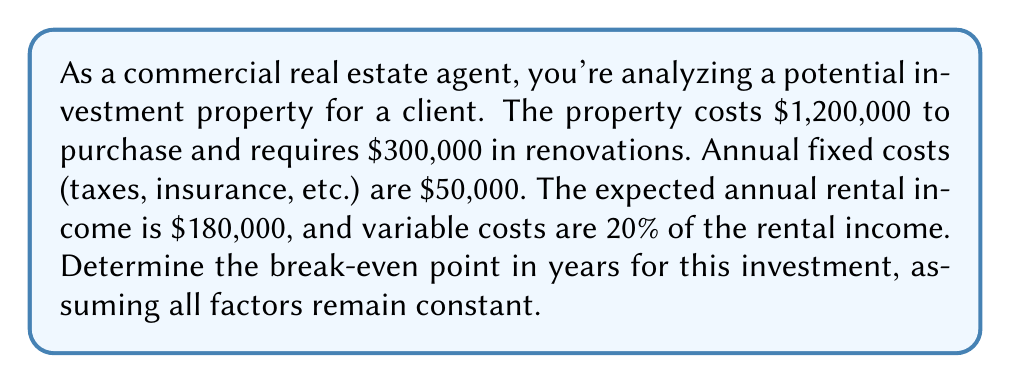Can you solve this math problem? Let's approach this step-by-step:

1) First, we need to calculate the total initial investment:
   Initial Investment = Purchase Price + Renovation Costs
   $$ 1,200,000 + 300,000 = 1,500,000 $$

2) Now, let's calculate the annual net income:
   
   Annual Rental Income: $180,000
   Variable Costs: 20% of $180,000 = $36,000
   Fixed Costs: $50,000

   Annual Net Income = Rental Income - Variable Costs - Fixed Costs
   $$ 180,000 - 36,000 - 50,000 = 94,000 $$

3) The break-even point is when the cumulative net income equals the initial investment. We can set up an equation:

   $$ 94,000x = 1,500,000 $$

   Where $x$ is the number of years to break even.

4) Solve for $x$:
   $$ x = \frac{1,500,000}{94,000} \approx 15.96 $$

5) Since we can't have a partial year in this context, we round up to the next whole year.
Answer: 16 years 